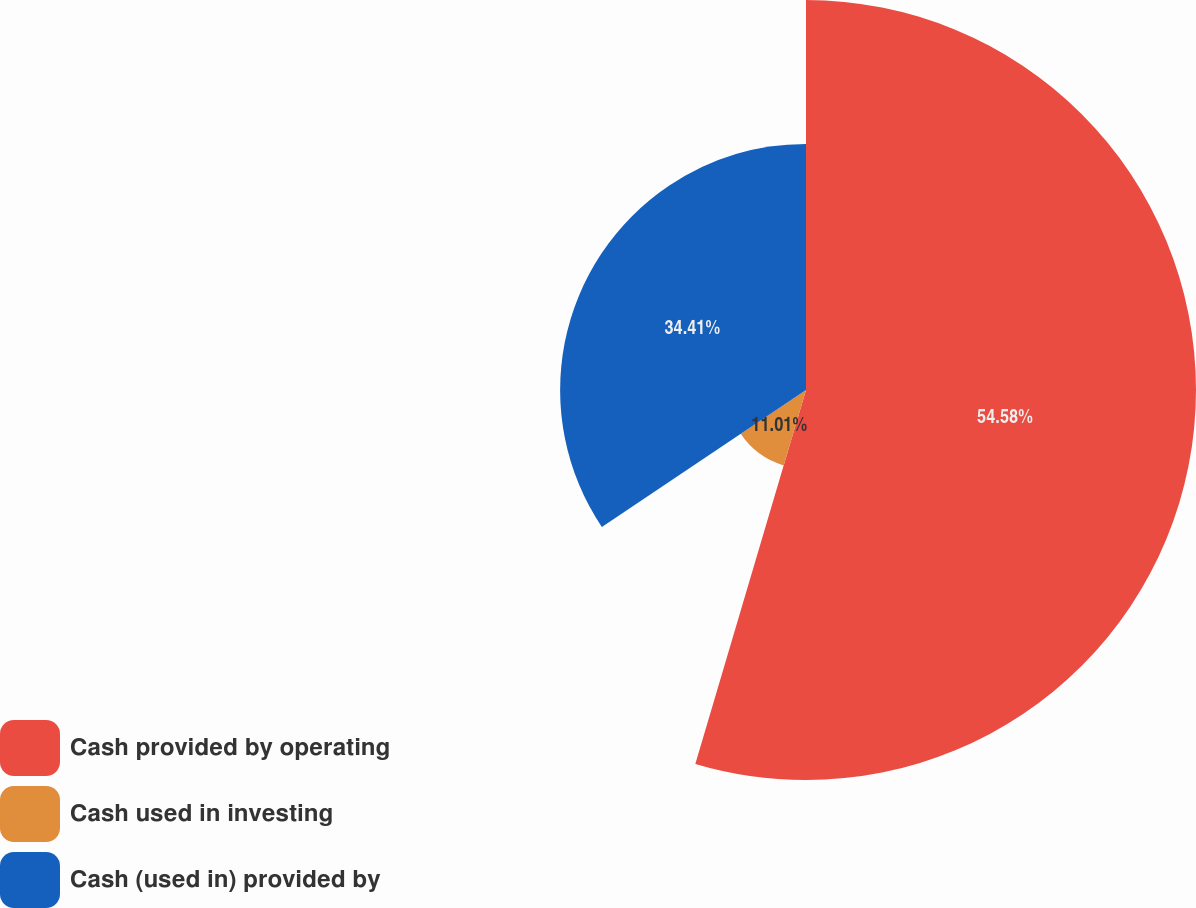<chart> <loc_0><loc_0><loc_500><loc_500><pie_chart><fcel>Cash provided by operating<fcel>Cash used in investing<fcel>Cash (used in) provided by<nl><fcel>54.58%<fcel>11.01%<fcel>34.41%<nl></chart> 